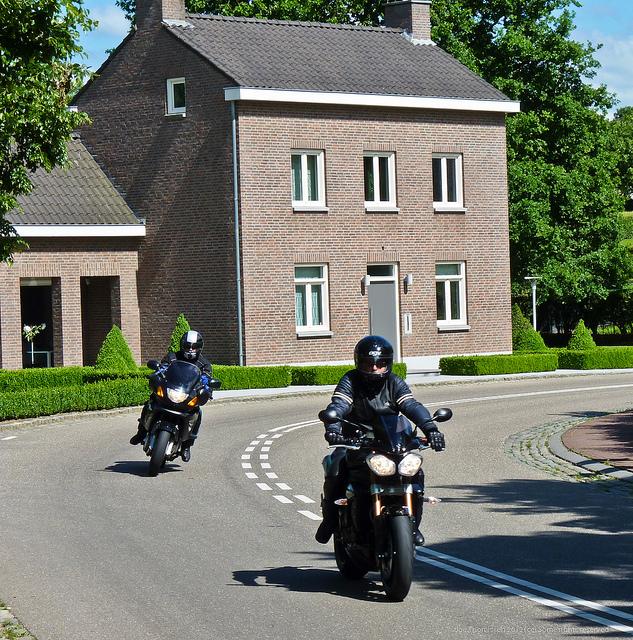Is this a motorbike race?
Short answer required. No. How many people are shown?
Give a very brief answer. 2. What color is the door?
Give a very brief answer. Gray. What color are the dashed lines on the ground?
Concise answer only. White. Are these people traveling on a highway?
Be succinct. No. How many fireplaces so you see?
Short answer required. 0. 